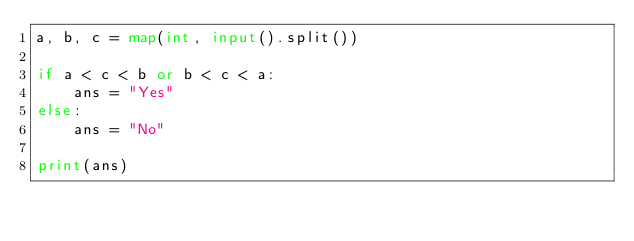Convert code to text. <code><loc_0><loc_0><loc_500><loc_500><_Python_>a, b, c = map(int, input().split())

if a < c < b or b < c < a:
    ans = "Yes"
else:
    ans = "No"

print(ans)
</code> 